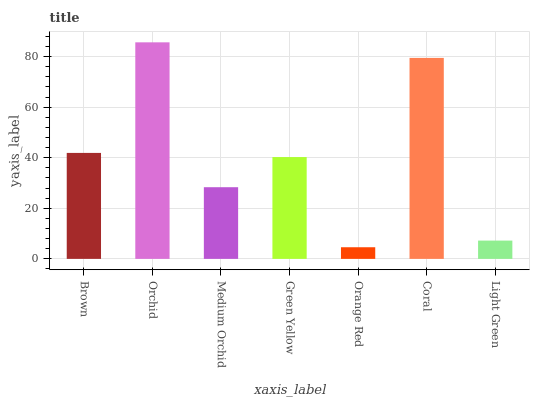Is Orange Red the minimum?
Answer yes or no. Yes. Is Orchid the maximum?
Answer yes or no. Yes. Is Medium Orchid the minimum?
Answer yes or no. No. Is Medium Orchid the maximum?
Answer yes or no. No. Is Orchid greater than Medium Orchid?
Answer yes or no. Yes. Is Medium Orchid less than Orchid?
Answer yes or no. Yes. Is Medium Orchid greater than Orchid?
Answer yes or no. No. Is Orchid less than Medium Orchid?
Answer yes or no. No. Is Green Yellow the high median?
Answer yes or no. Yes. Is Green Yellow the low median?
Answer yes or no. Yes. Is Light Green the high median?
Answer yes or no. No. Is Orchid the low median?
Answer yes or no. No. 